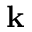<formula> <loc_0><loc_0><loc_500><loc_500>k</formula> 